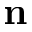<formula> <loc_0><loc_0><loc_500><loc_500>n</formula> 